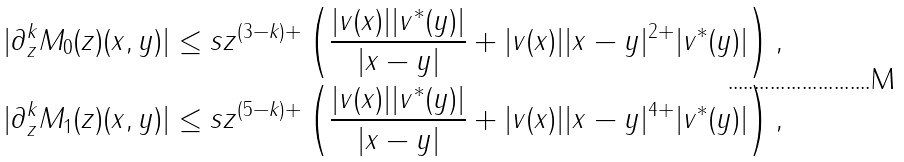<formula> <loc_0><loc_0><loc_500><loc_500>& | \partial _ { z } ^ { k } M _ { 0 } ( z ) ( x , y ) | \leq s z ^ { ( 3 - k ) + } \left ( \frac { | v ( x ) | | v ^ { * } ( y ) | } { | x - y | } + | v ( x ) | | x - y | ^ { 2 + } | v ^ { * } ( y ) | \right ) , \\ & | \partial _ { z } ^ { k } M _ { 1 } ( z ) ( x , y ) | \leq s z ^ { ( 5 - k ) + } \left ( \frac { | v ( x ) | | v ^ { * } ( y ) | } { | x - y | } + | v ( x ) | | x - y | ^ { 4 + } | v ^ { * } ( y ) | \right ) ,</formula> 